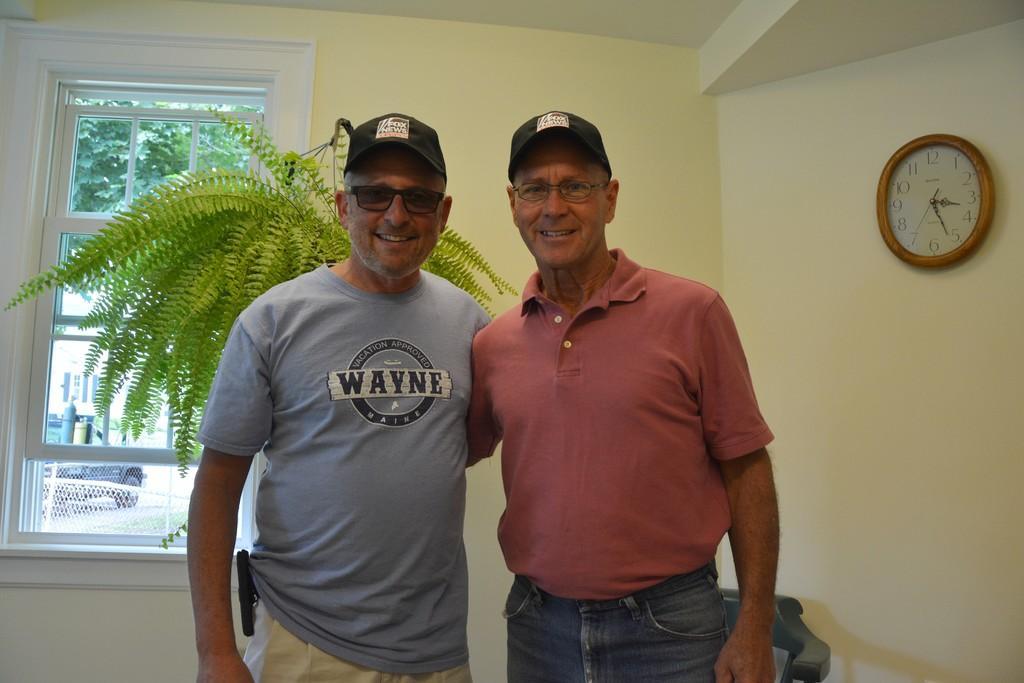In one or two sentences, can you explain what this image depicts? In the picture I can see two men are standing together and smiling. These men are wearing caps, glasses, t-shirts and pants. In the background a tree, a plant, a clock on the wall, a window, vehicle and some other objects. 